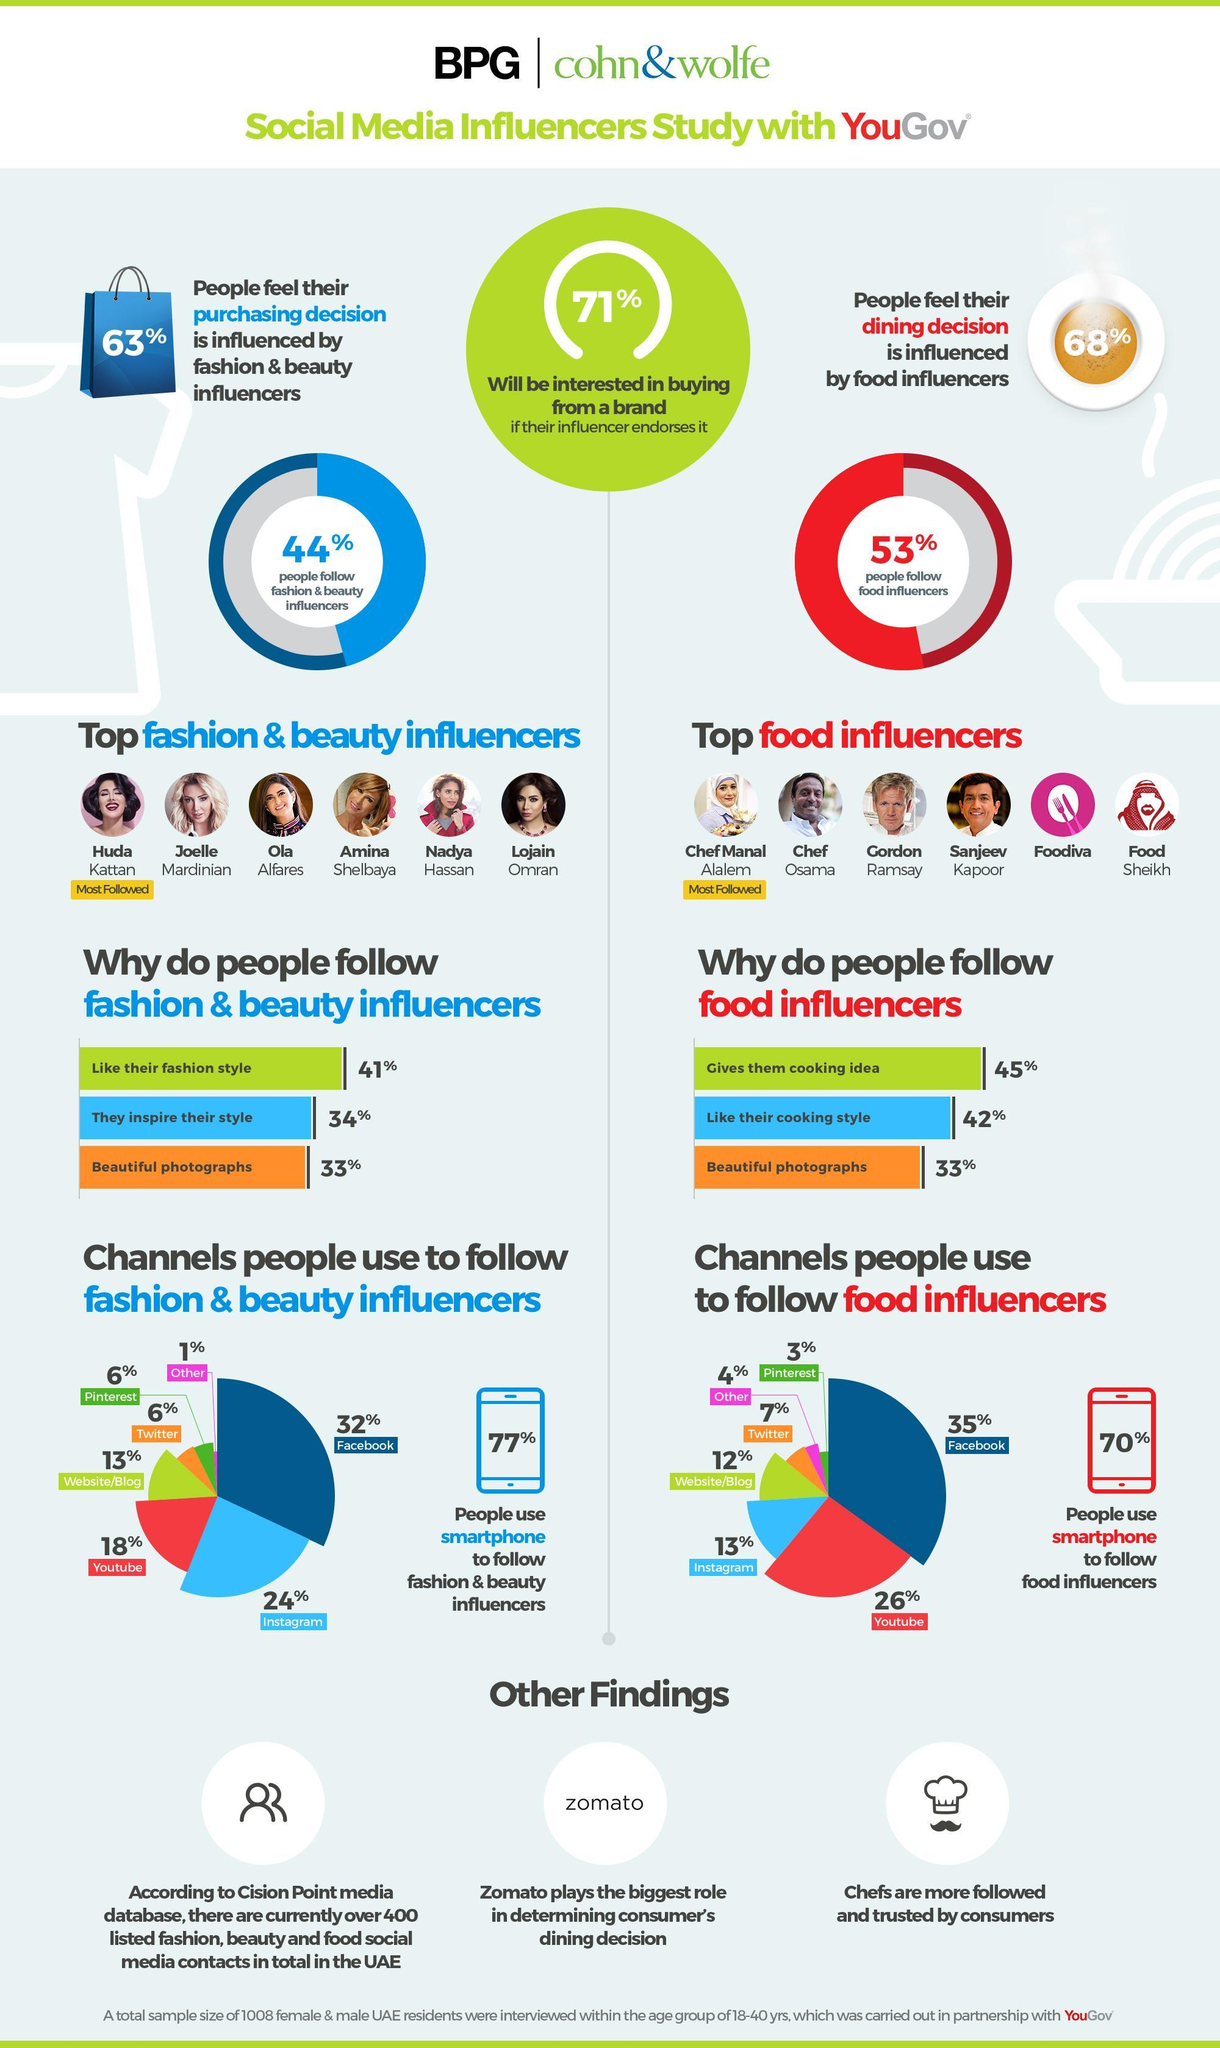What percent of the UAE residents in the age group of 18-40 years follow food influencers because of their cooking style as per the survey?
Answer the question with a short phrase. 42% What percentage of people use a smartphone to follow fashion & beauty influencers according to the survey? 77% What percent of the UAE residents in the age group of 18-40 years follow fashion & beauty influencers because of their beautiful photographs as per the survey? 33% What percentage of the respondents use a smartphone to follow food influencers according to the survey? 70% Which social media app is used by the majority of the respondents to follow food influencers as per the survey? Facebook What percentage of the respondents use Youtube to follow food influencers according to the survey? 26% Which social media app is used by the majority of the respondents to follow fashion & beauty influencers other than the Facebook as per the survey? Instagram 